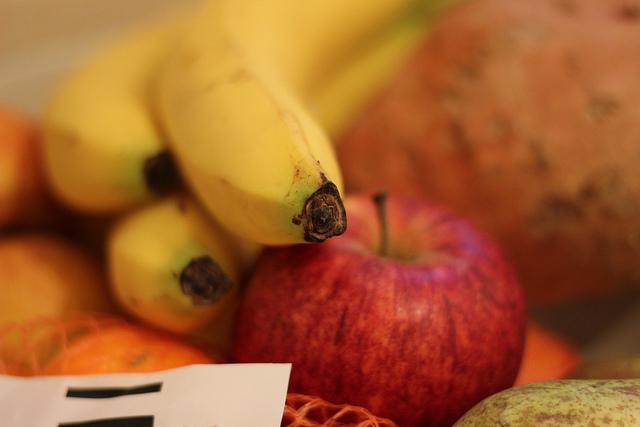Is this fruit or vegetables?
Give a very brief answer. Fruit. Are the bananas ripe?
Give a very brief answer. Yes. Are there more apples or bananas?
Be succinct. Bananas. 